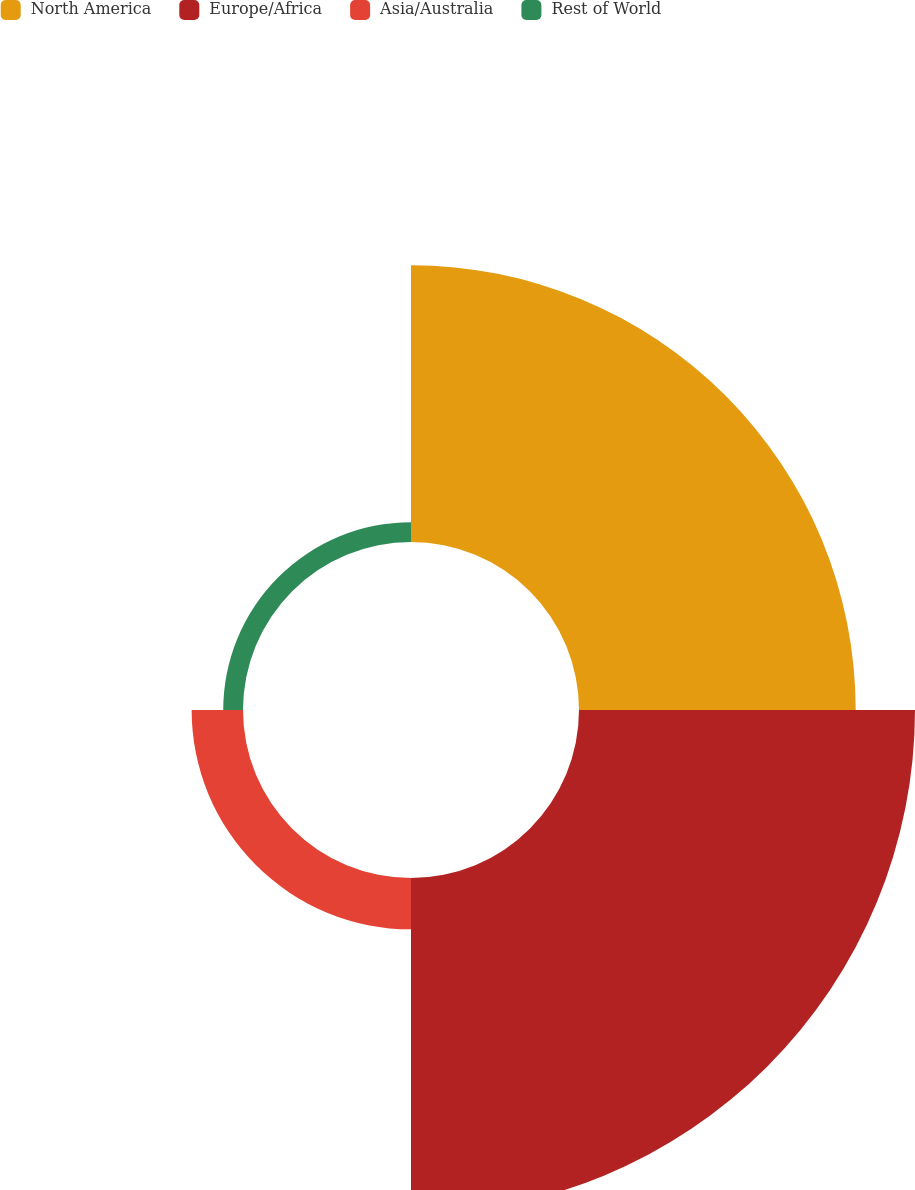<chart> <loc_0><loc_0><loc_500><loc_500><pie_chart><fcel>North America<fcel>Europe/Africa<fcel>Asia/Australia<fcel>Rest of World<nl><fcel>40.46%<fcel>49.13%<fcel>7.51%<fcel>2.89%<nl></chart> 